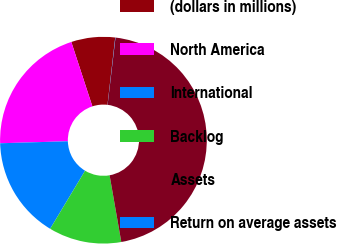<chart> <loc_0><loc_0><loc_500><loc_500><pie_chart><fcel>(dollars in millions)<fcel>North America<fcel>International<fcel>Backlog<fcel>Assets<fcel>Return on average assets<nl><fcel>6.85%<fcel>20.44%<fcel>15.91%<fcel>11.38%<fcel>45.37%<fcel>0.04%<nl></chart> 